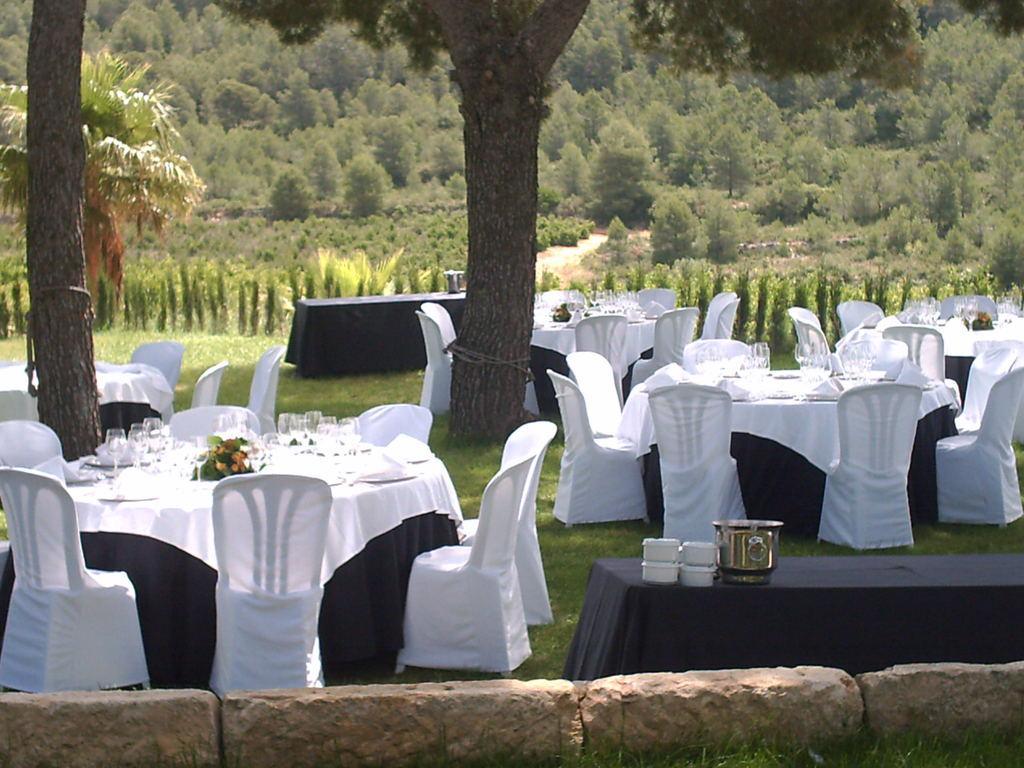In one or two sentences, can you explain what this image depicts? In this picture there are tables and chairs on the right and left side of the image, tables contains glasses, plates, and food items on it, there are trees in the background area of the image. 